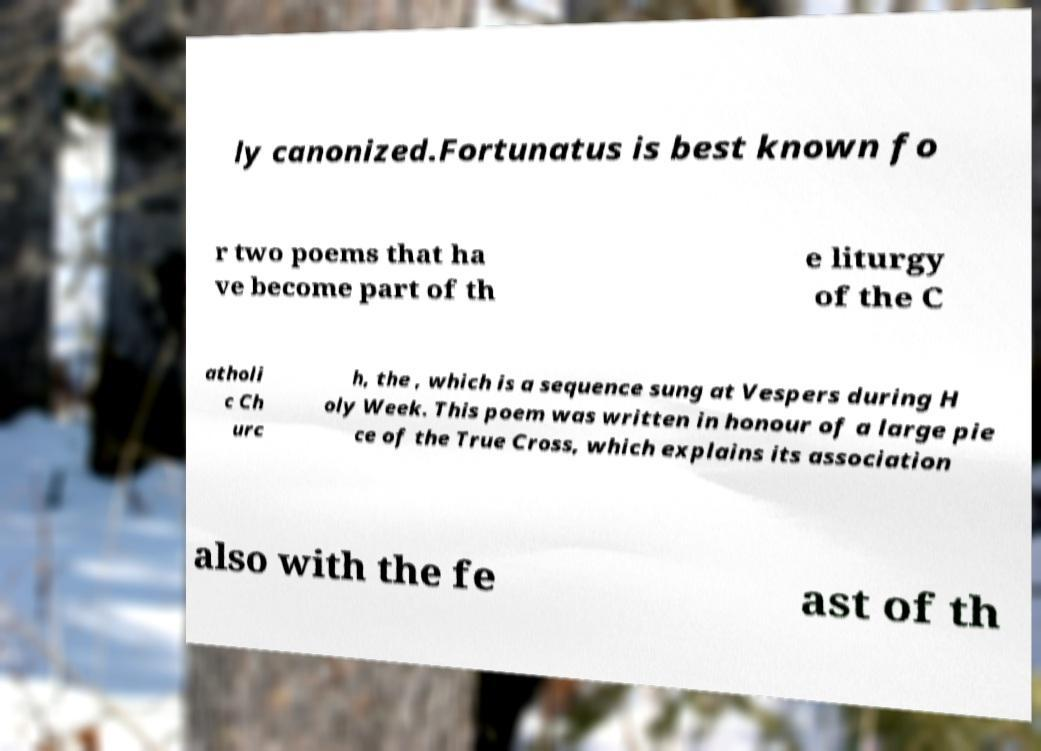Could you extract and type out the text from this image? ly canonized.Fortunatus is best known fo r two poems that ha ve become part of th e liturgy of the C atholi c Ch urc h, the , which is a sequence sung at Vespers during H oly Week. This poem was written in honour of a large pie ce of the True Cross, which explains its association also with the fe ast of th 